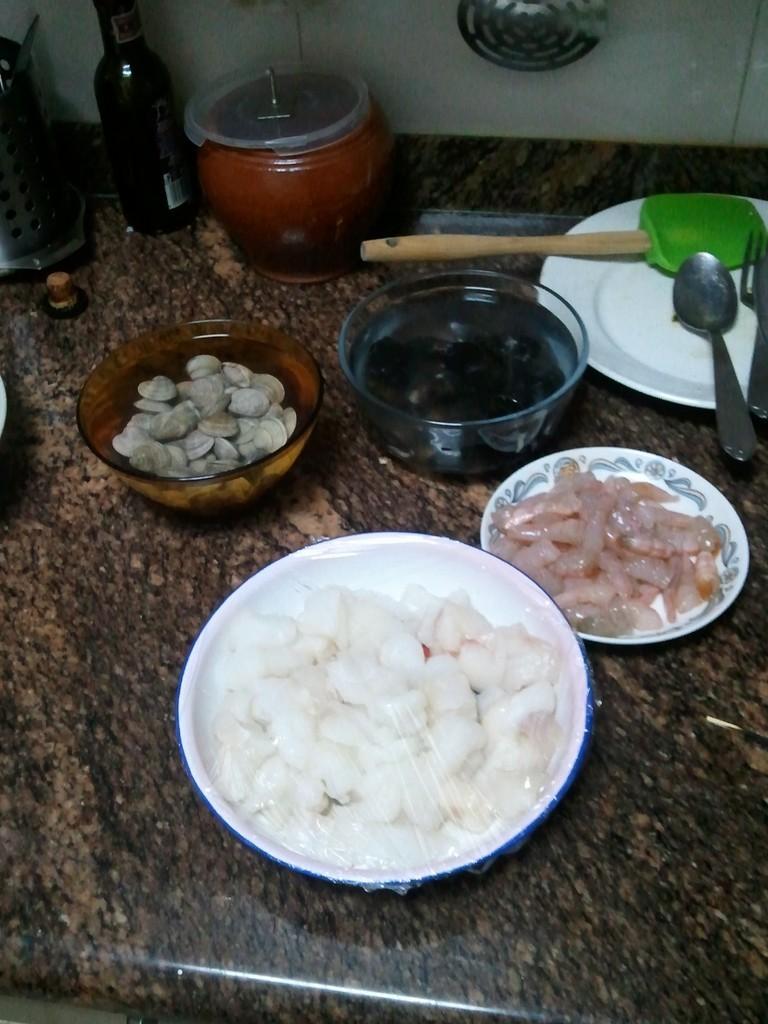Could you give a brief overview of what you see in this image? In this image I can see bowl, plates, spatula, spoons, bottle and food items kept on the table. In the background I can see a wall. This image is taken may be in a room. 